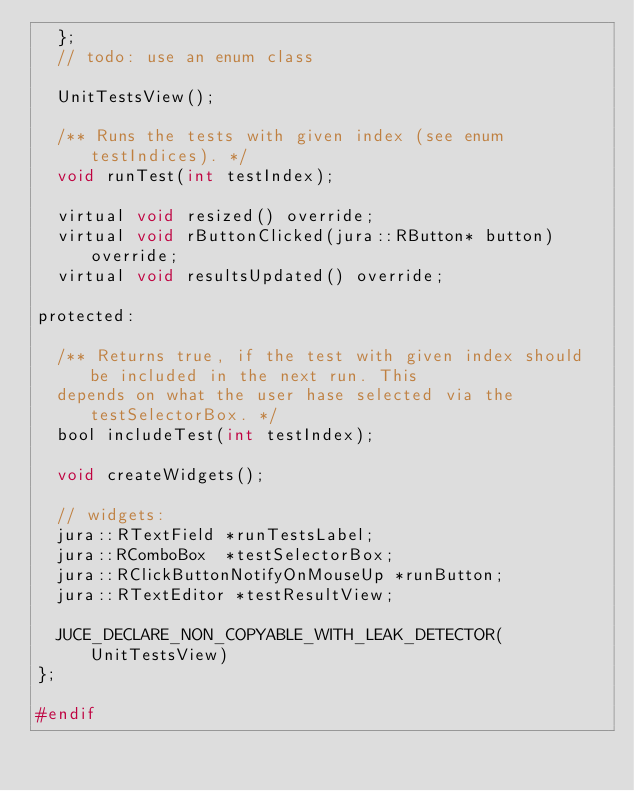<code> <loc_0><loc_0><loc_500><loc_500><_C_>  };
  // todo: use an enum class

  UnitTestsView();

  /** Runs the tests with given index (see enum testIndices). */
  void runTest(int testIndex);

  virtual void resized() override;
  virtual void rButtonClicked(jura::RButton* button) override;
  virtual void resultsUpdated() override;

protected:

  /** Returns true, if the test with given index should be included in the next run. This 
  depends on what the user hase selected via the testSelectorBox. */
  bool includeTest(int testIndex);

  void createWidgets();

  // widgets:
  jura::RTextField *runTestsLabel;
  jura::RComboBox  *testSelectorBox;
  jura::RClickButtonNotifyOnMouseUp *runButton;
  jura::RTextEditor *testResultView;

  JUCE_DECLARE_NON_COPYABLE_WITH_LEAK_DETECTOR(UnitTestsView)
};

#endif</code> 